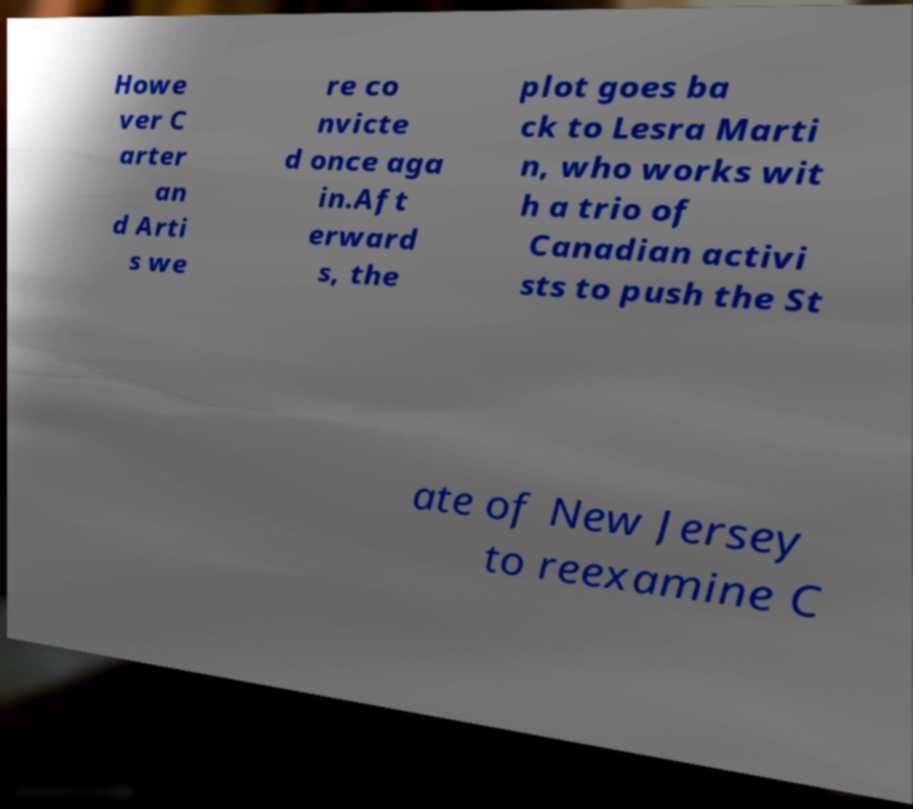Can you accurately transcribe the text from the provided image for me? Howe ver C arter an d Arti s we re co nvicte d once aga in.Aft erward s, the plot goes ba ck to Lesra Marti n, who works wit h a trio of Canadian activi sts to push the St ate of New Jersey to reexamine C 